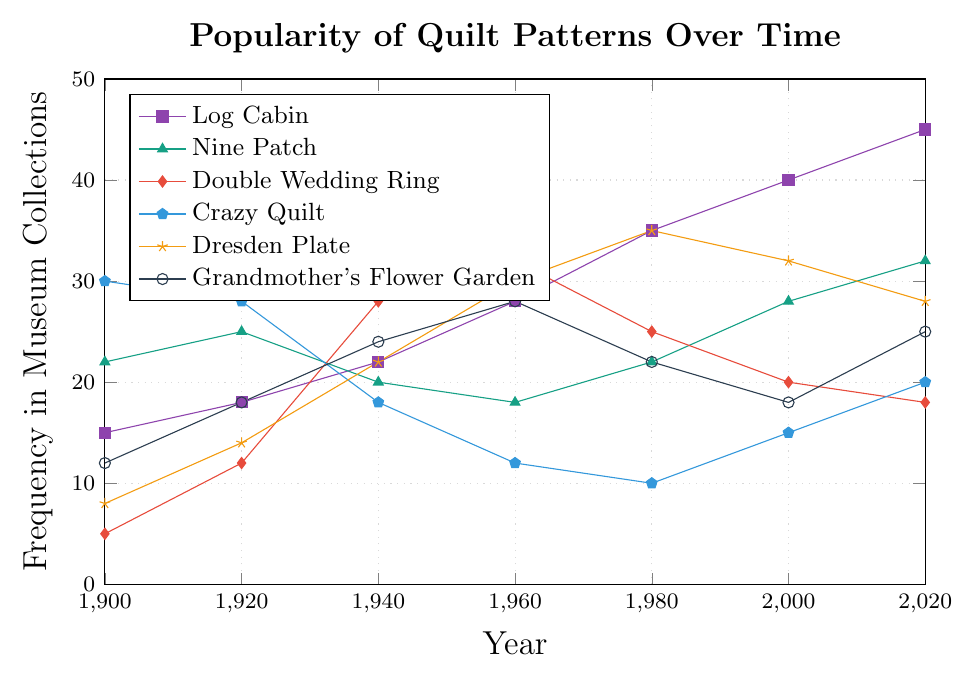What quilt pattern has the highest frequency in museum collections in the year 1960? Look at the data points for each pattern in 1960. The pattern "Double Wedding Ring" has a frequency of 32, which is the highest among the patterns listed.
Answer: Double Wedding Ring Comparing Log Cabin and Nine Patch patterns, which one showed a greater increase in popularity from 2000 to 2020? From 2000 to 2020, the Log Cabin pattern increased from 40 to 45 (an increase of 5), while the Nine Patch pattern increased from 28 to 32 (an increase of 4). Therefore, the Log Cabin pattern showed a greater increase.
Answer: Log Cabin How many quilt patterns reached their peak popularity in the year 1980? Check the frequency data for each quilt pattern in 1980 and compare it with the frequency in other years. Log Cabin, Nine Patch, Dresden Plate, and Crazy Quilt reached their peak popularity in 1980. Thus, there are four patterns.
Answer: 4 Which quilt pattern saw the largest decline in frequency from its peak to 2020? Identify the peak frequency for each quilt pattern and its frequency in 2020. Calculate the difference: Log Cabin (45-45=0), Nine Patch (32-32=0), Double Wedding Ring (32-18=14), Crazy Quilt (30-20=10), Dresden Plate (35-28=7), Grandmother's Flower Garden (28-25=3). The Double Wedding Ring saw the largest decline of 14.
Answer: Double Wedding Ring What is the overall trend of the popularity of the Crazy Quilt pattern from 1900 to 2020? Observe the frequency points of Crazy Quilt from 1900 (30) to 2020 (20). The frequency generally decreases over the years.
Answer: Decreasing During which period did the Grandmother's Flower Garden pattern experience the most considerable increase in frequency? Compare the year-to-year changes in frequency. From 1940 (24) to 1960 (28), the pattern shows an increase of 4, which is the highest increase.
Answer: 1940 to 1960 What is the average frequency of the Dresden Plate pattern over these years? Sum up the frequencies for Dresden Plate across all years (8+14+22+30+35+32+28=169) and divide by the number of years (169/7).
Answer: 24.14 Between 1980 and 2000, how did the popularity of the Crazy Quilt and Grandmother's Flower Garden patterns change? For Crazy Quilt: 1980 (10) to 2000 (15) is an increase of 5. For Grandmother's Flower Garden: 1980 (22) to 2000 (18) is a decrease of 4.
Answer: Increase for Crazy Quilt, Decrease for Grandmother's Flower Garden Which pattern demonstrates the most consistent increase in popularity across the given years? Analyze the trends for each pattern's frequency across all years. Log Cabin consistently increases from 1900 to 2020 without any dips.
Answer: Log Cabin If you compare the frequency of Log Cabin and Dresden Plate patterns in 1920, which is more popular and by how much? Log Cabin has a frequency of 18, and Dresden Plate has a frequency of 14 in 1920. The Log Cabin is more popular by 4.
Answer: Log Cabin by 4 